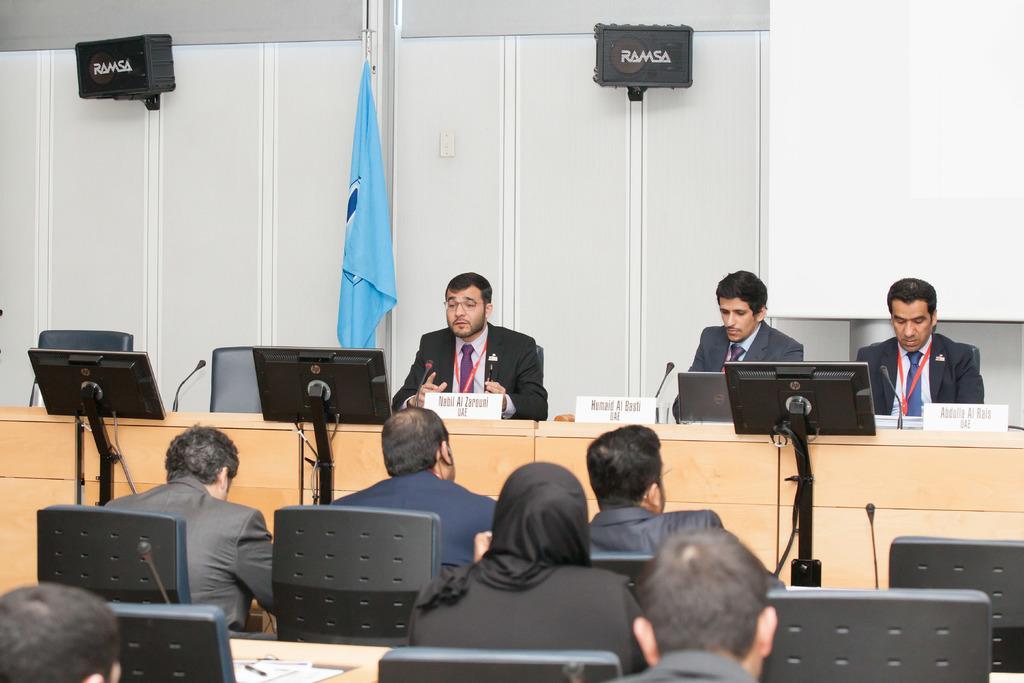In one or two sentences, can you explain what this image depicts? In this picture, There are some people sitting on the chairs which are in black color, There is a table which is in yellow color and there are some computers which are in black color and in the background there is a white color wall and in the top there are some black color speakers. 